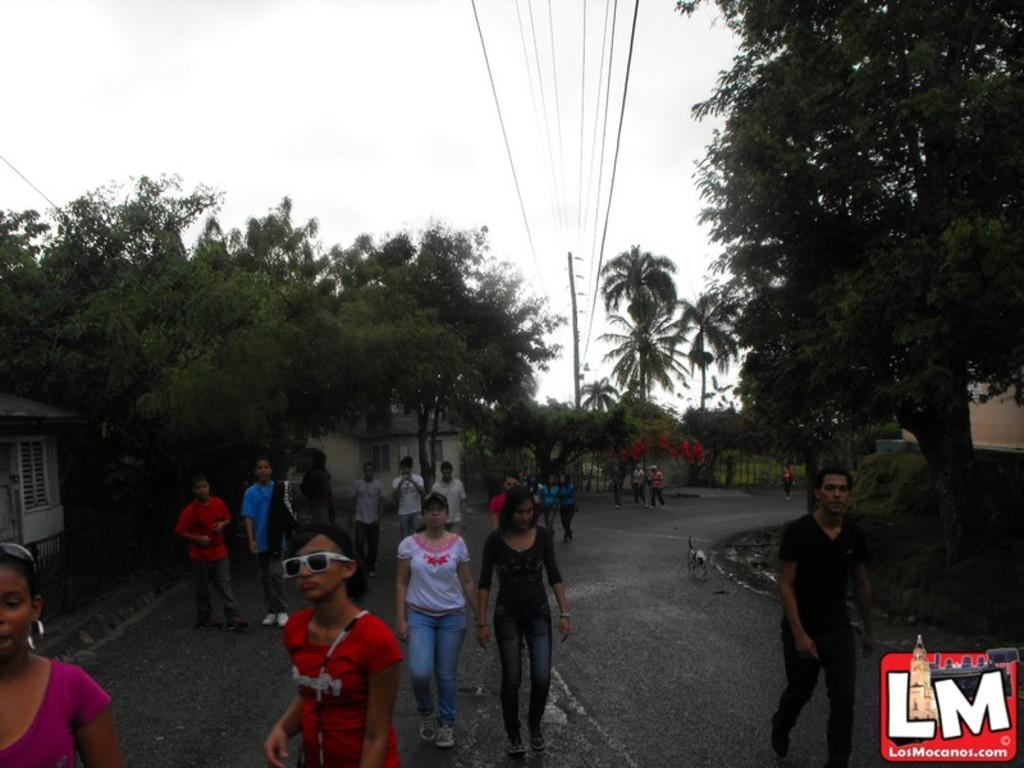What are the people in the image doing? The people in the image are walking on a road. What can be seen on the pole in the image? There are wires on a pole in the image. What type of alarm is the beginner learning to use in the image? There is no alarm or beginner present in the image; it only shows people walking on a road and wires on a pole. 